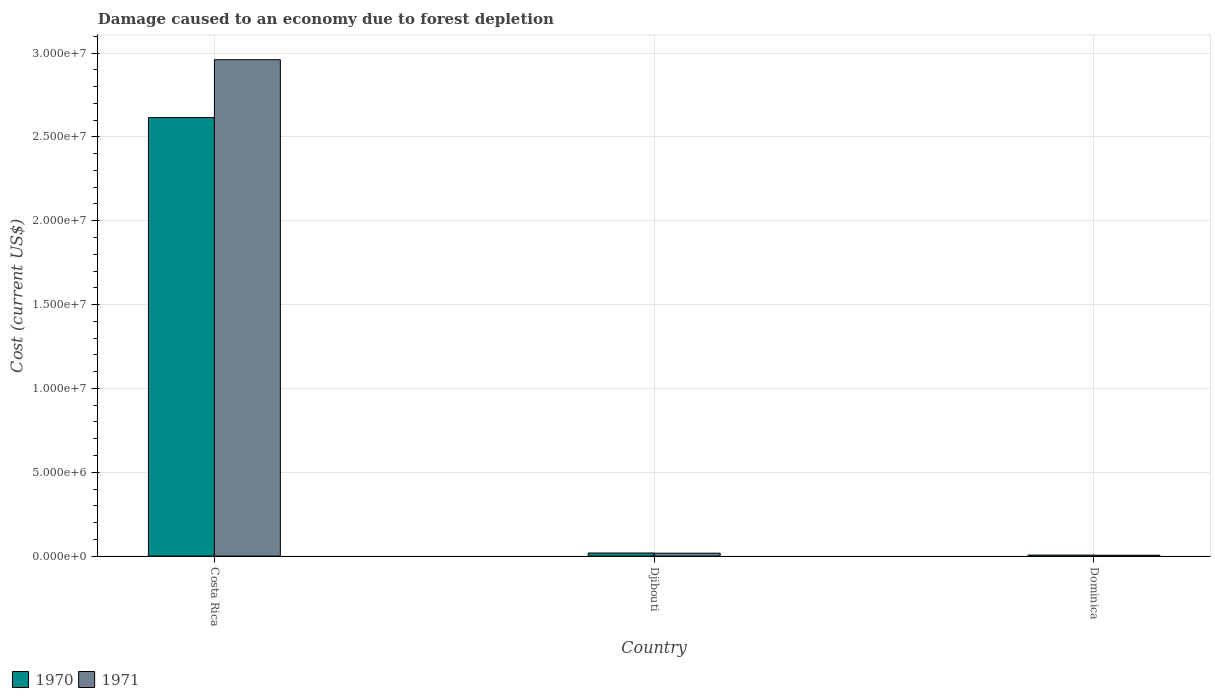How many different coloured bars are there?
Provide a short and direct response. 2. How many bars are there on the 3rd tick from the left?
Provide a succinct answer. 2. How many bars are there on the 1st tick from the right?
Your response must be concise. 2. In how many cases, is the number of bars for a given country not equal to the number of legend labels?
Make the answer very short. 0. What is the cost of damage caused due to forest depletion in 1970 in Dominica?
Provide a succinct answer. 5.98e+04. Across all countries, what is the maximum cost of damage caused due to forest depletion in 1970?
Your response must be concise. 2.61e+07. Across all countries, what is the minimum cost of damage caused due to forest depletion in 1970?
Your answer should be compact. 5.98e+04. In which country was the cost of damage caused due to forest depletion in 1970 minimum?
Your answer should be compact. Dominica. What is the total cost of damage caused due to forest depletion in 1971 in the graph?
Your answer should be compact. 2.98e+07. What is the difference between the cost of damage caused due to forest depletion in 1971 in Costa Rica and that in Djibouti?
Ensure brevity in your answer.  2.94e+07. What is the difference between the cost of damage caused due to forest depletion in 1971 in Costa Rica and the cost of damage caused due to forest depletion in 1970 in Dominica?
Give a very brief answer. 2.95e+07. What is the average cost of damage caused due to forest depletion in 1971 per country?
Your response must be concise. 9.94e+06. What is the difference between the cost of damage caused due to forest depletion of/in 1971 and cost of damage caused due to forest depletion of/in 1970 in Dominica?
Offer a terse response. -8949.07. In how many countries, is the cost of damage caused due to forest depletion in 1971 greater than 22000000 US$?
Offer a very short reply. 1. What is the ratio of the cost of damage caused due to forest depletion in 1971 in Costa Rica to that in Djibouti?
Your answer should be compact. 170.8. What is the difference between the highest and the second highest cost of damage caused due to forest depletion in 1970?
Your answer should be very brief. 1.25e+05. What is the difference between the highest and the lowest cost of damage caused due to forest depletion in 1971?
Offer a terse response. 2.96e+07. In how many countries, is the cost of damage caused due to forest depletion in 1970 greater than the average cost of damage caused due to forest depletion in 1970 taken over all countries?
Your answer should be compact. 1. Is the sum of the cost of damage caused due to forest depletion in 1971 in Costa Rica and Djibouti greater than the maximum cost of damage caused due to forest depletion in 1970 across all countries?
Provide a short and direct response. Yes. What does the 1st bar from the left in Djibouti represents?
Offer a terse response. 1970. What does the 2nd bar from the right in Costa Rica represents?
Your answer should be compact. 1970. How many bars are there?
Your answer should be compact. 6. Are all the bars in the graph horizontal?
Ensure brevity in your answer.  No. How many countries are there in the graph?
Make the answer very short. 3. What is the difference between two consecutive major ticks on the Y-axis?
Ensure brevity in your answer.  5.00e+06. Are the values on the major ticks of Y-axis written in scientific E-notation?
Offer a terse response. Yes. Does the graph contain any zero values?
Your response must be concise. No. Does the graph contain grids?
Give a very brief answer. Yes. Where does the legend appear in the graph?
Your answer should be very brief. Bottom left. What is the title of the graph?
Provide a succinct answer. Damage caused to an economy due to forest depletion. What is the label or title of the X-axis?
Provide a short and direct response. Country. What is the label or title of the Y-axis?
Offer a terse response. Cost (current US$). What is the Cost (current US$) in 1970 in Costa Rica?
Your response must be concise. 2.61e+07. What is the Cost (current US$) of 1971 in Costa Rica?
Your response must be concise. 2.96e+07. What is the Cost (current US$) in 1970 in Djibouti?
Make the answer very short. 1.85e+05. What is the Cost (current US$) of 1971 in Djibouti?
Provide a succinct answer. 1.73e+05. What is the Cost (current US$) in 1970 in Dominica?
Offer a very short reply. 5.98e+04. What is the Cost (current US$) of 1971 in Dominica?
Offer a terse response. 5.09e+04. Across all countries, what is the maximum Cost (current US$) of 1970?
Offer a terse response. 2.61e+07. Across all countries, what is the maximum Cost (current US$) of 1971?
Make the answer very short. 2.96e+07. Across all countries, what is the minimum Cost (current US$) in 1970?
Provide a succinct answer. 5.98e+04. Across all countries, what is the minimum Cost (current US$) of 1971?
Your answer should be very brief. 5.09e+04. What is the total Cost (current US$) of 1970 in the graph?
Make the answer very short. 2.64e+07. What is the total Cost (current US$) in 1971 in the graph?
Provide a succinct answer. 2.98e+07. What is the difference between the Cost (current US$) of 1970 in Costa Rica and that in Djibouti?
Your answer should be compact. 2.60e+07. What is the difference between the Cost (current US$) in 1971 in Costa Rica and that in Djibouti?
Give a very brief answer. 2.94e+07. What is the difference between the Cost (current US$) of 1970 in Costa Rica and that in Dominica?
Keep it short and to the point. 2.61e+07. What is the difference between the Cost (current US$) in 1971 in Costa Rica and that in Dominica?
Provide a succinct answer. 2.96e+07. What is the difference between the Cost (current US$) in 1970 in Djibouti and that in Dominica?
Make the answer very short. 1.25e+05. What is the difference between the Cost (current US$) in 1971 in Djibouti and that in Dominica?
Ensure brevity in your answer.  1.22e+05. What is the difference between the Cost (current US$) in 1970 in Costa Rica and the Cost (current US$) in 1971 in Djibouti?
Make the answer very short. 2.60e+07. What is the difference between the Cost (current US$) in 1970 in Costa Rica and the Cost (current US$) in 1971 in Dominica?
Provide a succinct answer. 2.61e+07. What is the difference between the Cost (current US$) in 1970 in Djibouti and the Cost (current US$) in 1971 in Dominica?
Provide a short and direct response. 1.34e+05. What is the average Cost (current US$) in 1970 per country?
Provide a succinct answer. 8.80e+06. What is the average Cost (current US$) of 1971 per country?
Offer a terse response. 9.94e+06. What is the difference between the Cost (current US$) in 1970 and Cost (current US$) in 1971 in Costa Rica?
Ensure brevity in your answer.  -3.45e+06. What is the difference between the Cost (current US$) in 1970 and Cost (current US$) in 1971 in Djibouti?
Give a very brief answer. 1.14e+04. What is the difference between the Cost (current US$) in 1970 and Cost (current US$) in 1971 in Dominica?
Offer a very short reply. 8949.07. What is the ratio of the Cost (current US$) in 1970 in Costa Rica to that in Djibouti?
Your answer should be compact. 141.54. What is the ratio of the Cost (current US$) in 1971 in Costa Rica to that in Djibouti?
Offer a terse response. 170.8. What is the ratio of the Cost (current US$) in 1970 in Costa Rica to that in Dominica?
Your response must be concise. 437.18. What is the ratio of the Cost (current US$) in 1971 in Costa Rica to that in Dominica?
Your answer should be compact. 581.97. What is the ratio of the Cost (current US$) of 1970 in Djibouti to that in Dominica?
Offer a very short reply. 3.09. What is the ratio of the Cost (current US$) in 1971 in Djibouti to that in Dominica?
Your response must be concise. 3.41. What is the difference between the highest and the second highest Cost (current US$) of 1970?
Provide a succinct answer. 2.60e+07. What is the difference between the highest and the second highest Cost (current US$) in 1971?
Offer a very short reply. 2.94e+07. What is the difference between the highest and the lowest Cost (current US$) in 1970?
Provide a succinct answer. 2.61e+07. What is the difference between the highest and the lowest Cost (current US$) of 1971?
Make the answer very short. 2.96e+07. 